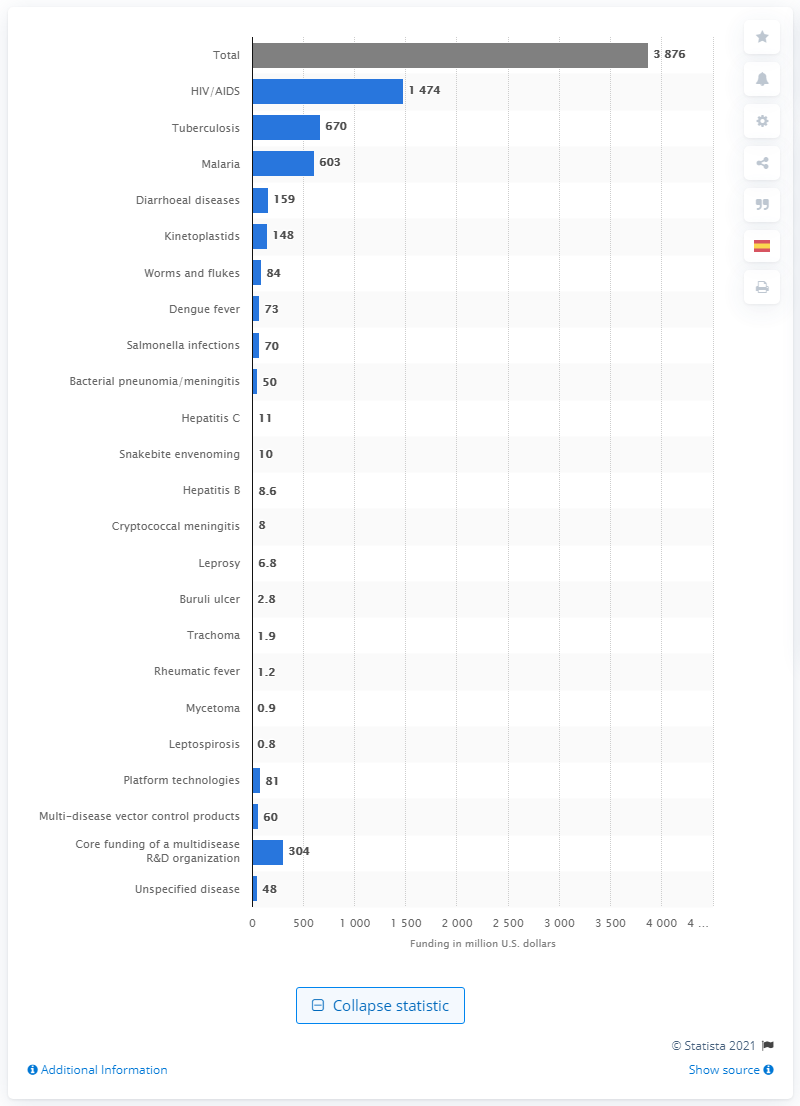Give some essential details in this illustration. In 2019, a total of 1474 million dollars was specifically allocated for research and development aimed at combating the HIV/AIDS epidemic. 